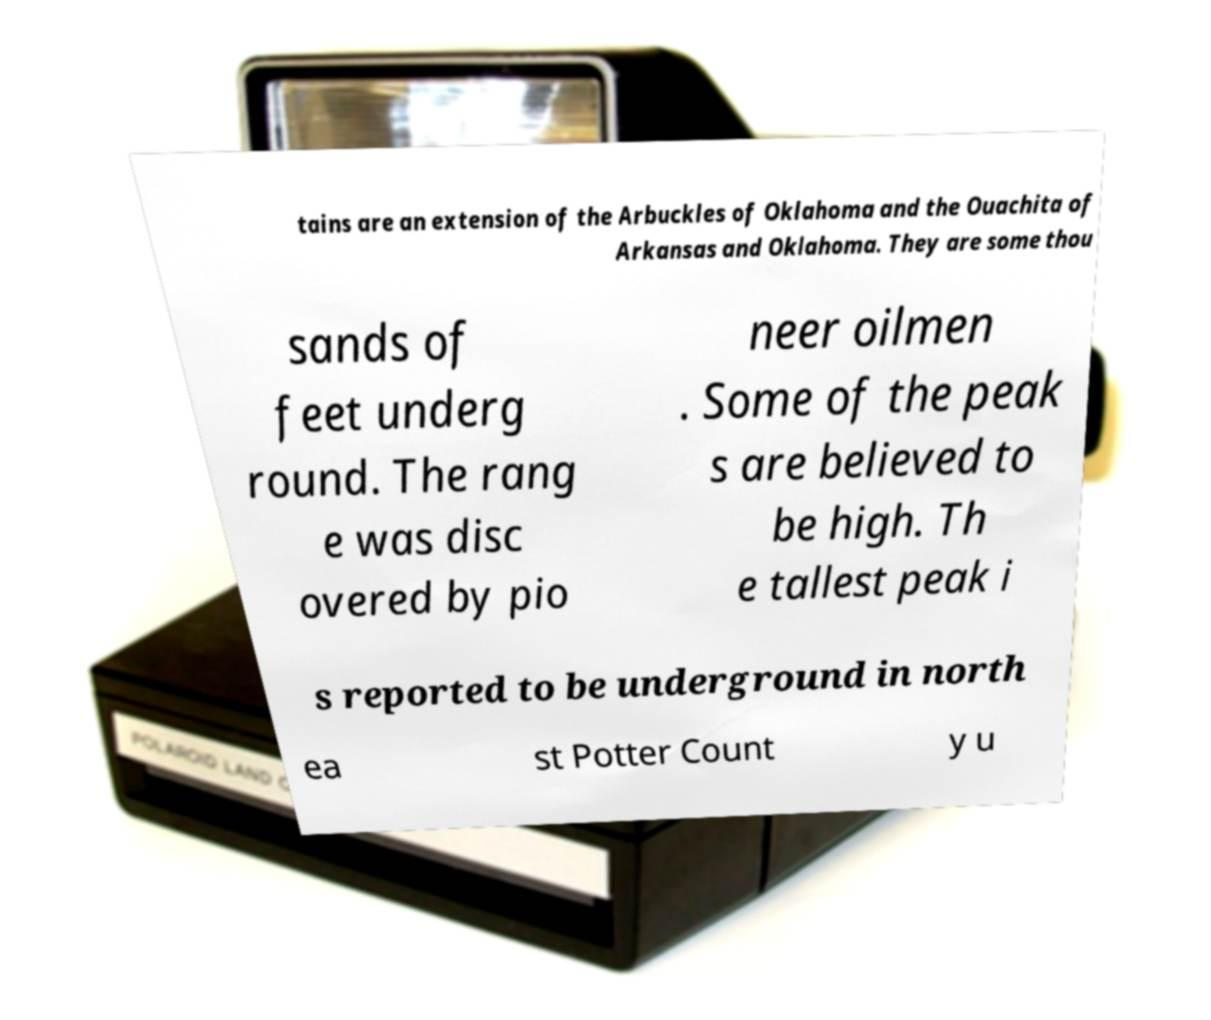For documentation purposes, I need the text within this image transcribed. Could you provide that? tains are an extension of the Arbuckles of Oklahoma and the Ouachita of Arkansas and Oklahoma. They are some thou sands of feet underg round. The rang e was disc overed by pio neer oilmen . Some of the peak s are believed to be high. Th e tallest peak i s reported to be underground in north ea st Potter Count y u 